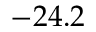Convert formula to latex. <formula><loc_0><loc_0><loc_500><loc_500>- 2 4 . 2</formula> 